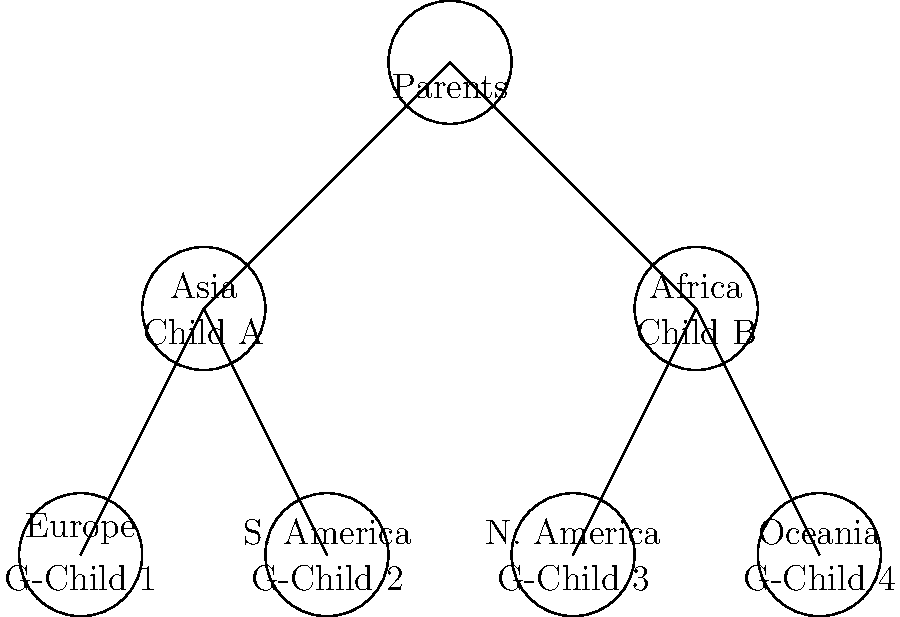In this family tree diagram, adoptive parents have children from different backgrounds. How many unique continents of origin are represented among the adopted children and grandchildren? To determine the number of unique continents represented, we need to follow these steps:

1. Identify the continents mentioned in the family tree:
   - Child A: Asia
   - Child B: Africa
   - G-Child 1: Europe
   - G-Child 2: South America
   - G-Child 3: North America
   - G-Child 4: Oceania

2. List the unique continents:
   1. Asia
   2. Africa
   3. Europe
   4. South America
   5. North America
   6. Oceania

3. Count the number of unique continents in the list.

We can see that there are 6 unique continents represented among the adopted children and grandchildren.
Answer: 6 